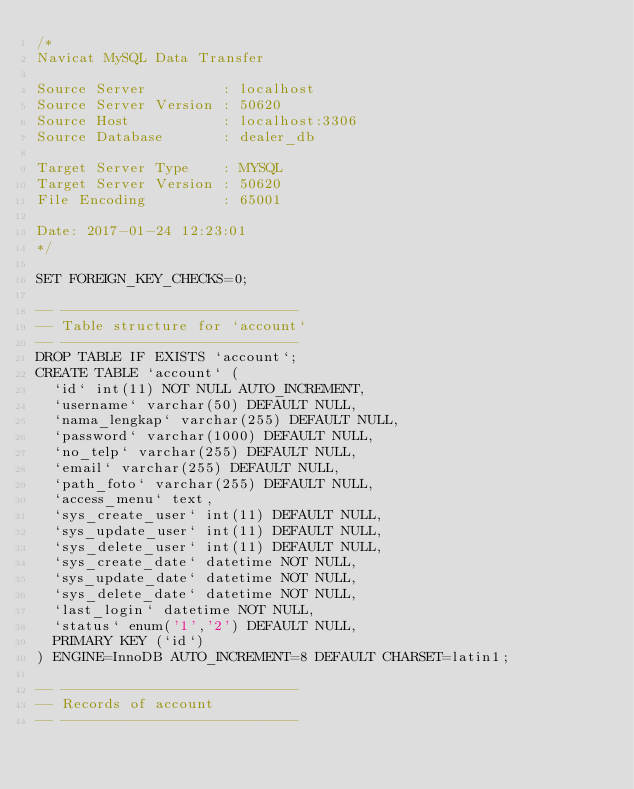<code> <loc_0><loc_0><loc_500><loc_500><_SQL_>/*
Navicat MySQL Data Transfer

Source Server         : localhost
Source Server Version : 50620
Source Host           : localhost:3306
Source Database       : dealer_db

Target Server Type    : MYSQL
Target Server Version : 50620
File Encoding         : 65001

Date: 2017-01-24 12:23:01
*/

SET FOREIGN_KEY_CHECKS=0;

-- ----------------------------
-- Table structure for `account`
-- ----------------------------
DROP TABLE IF EXISTS `account`;
CREATE TABLE `account` (
  `id` int(11) NOT NULL AUTO_INCREMENT,
  `username` varchar(50) DEFAULT NULL,
  `nama_lengkap` varchar(255) DEFAULT NULL,
  `password` varchar(1000) DEFAULT NULL,
  `no_telp` varchar(255) DEFAULT NULL,
  `email` varchar(255) DEFAULT NULL,
  `path_foto` varchar(255) DEFAULT NULL,
  `access_menu` text,
  `sys_create_user` int(11) DEFAULT NULL,
  `sys_update_user` int(11) DEFAULT NULL,
  `sys_delete_user` int(11) DEFAULT NULL,
  `sys_create_date` datetime NOT NULL,
  `sys_update_date` datetime NOT NULL,
  `sys_delete_date` datetime NOT NULL,
  `last_login` datetime NOT NULL,
  `status` enum('1','2') DEFAULT NULL,
  PRIMARY KEY (`id`)
) ENGINE=InnoDB AUTO_INCREMENT=8 DEFAULT CHARSET=latin1;

-- ----------------------------
-- Records of account
-- ----------------------------</code> 